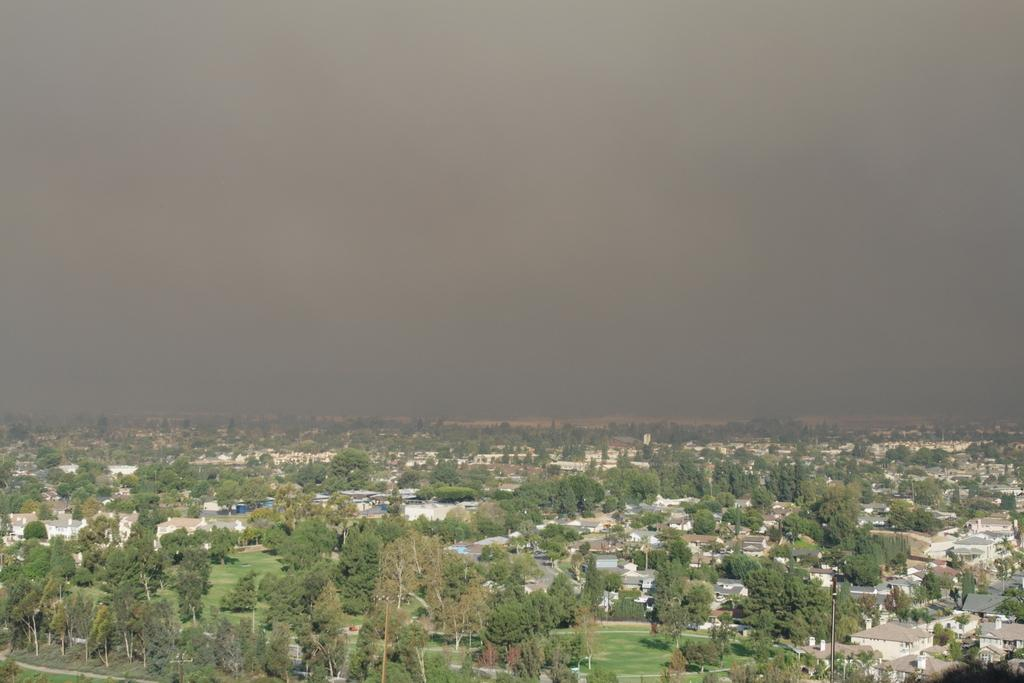What type of natural elements can be seen in the image? There are trees in the image. What type of man-made structures are present in the image? There are buildings in the image. What is visible at the top of the image? The sky is visible at the top of the image. What type of stone can be seen in the image? There is no stone present in the image. Can you describe the toad sitting on the roof of the building in the image? There is no toad present in the image; it only features trees, buildings, and the sky. 